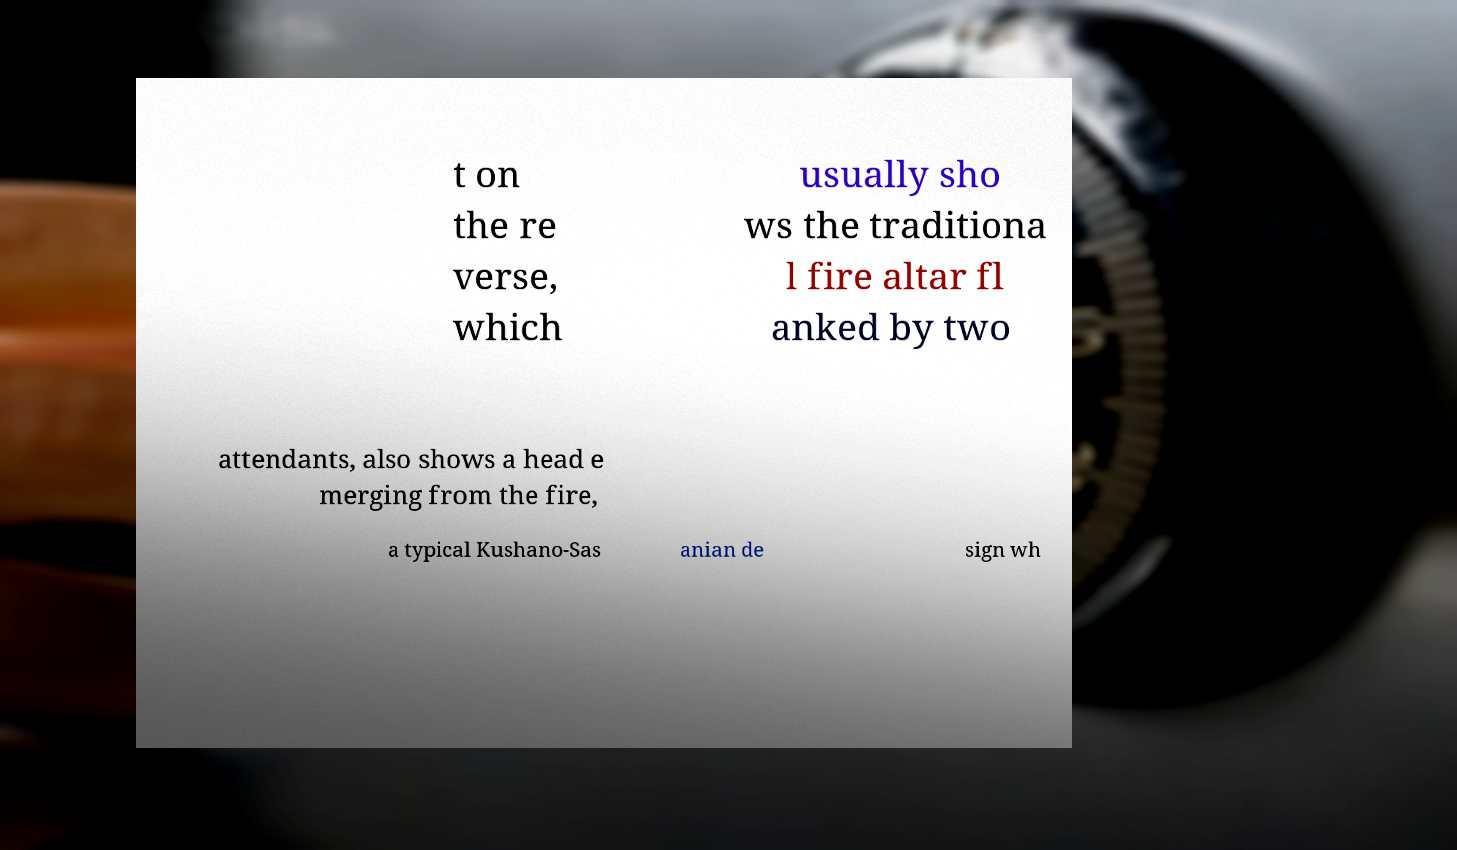Could you assist in decoding the text presented in this image and type it out clearly? t on the re verse, which usually sho ws the traditiona l fire altar fl anked by two attendants, also shows a head e merging from the fire, a typical Kushano-Sas anian de sign wh 